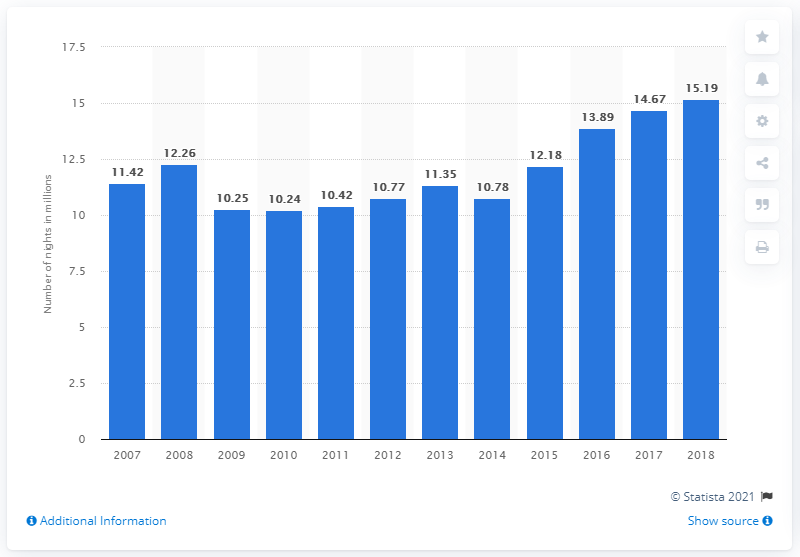Identify some key points in this picture. The number of nights spent at tourist accommodation establishments in Slovakia between 2007 and 2018 was 15.19... 